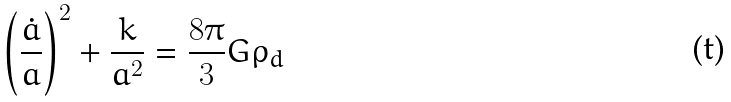<formula> <loc_0><loc_0><loc_500><loc_500>\left ( \frac { \dot { a } } { a } \right ) ^ { 2 } + \frac { k } { a ^ { 2 } } = \frac { 8 \pi } { 3 } G \rho _ { d }</formula> 